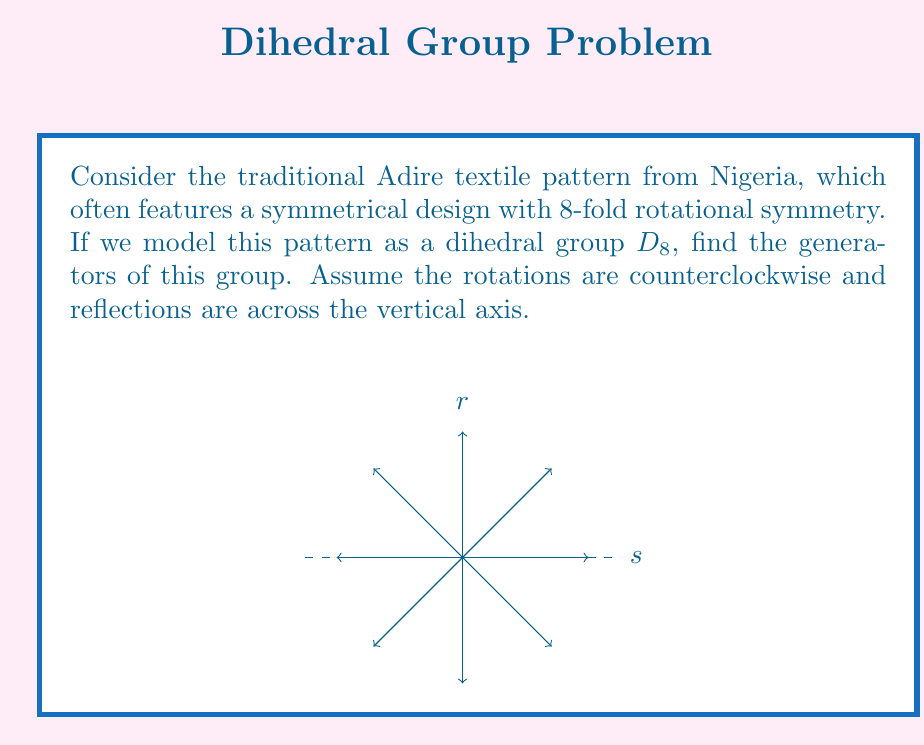Can you answer this question? To find the generators of the dihedral group $D_8$, we need to understand its structure:

1) $D_8$ has 16 elements: 8 rotations (including the identity) and 8 reflections.

2) The standard generators for $D_8$ are:
   - $r$: rotation by $45^\circ$ (counterclockwise)
   - $s$: reflection across the vertical axis

3) Properties of these generators:
   - $r^8 = e$ (identity)
   - $s^2 = e$
   - $srs = r^{-1}$

4) We can generate all elements of $D_8$ using these two generators:
   - Rotations: $e, r, r^2, r^3, r^4, r^5, r^6, r^7$
   - Reflections: $s, sr, sr^2, sr^3, sr^4, sr^5, sr^6, sr^7$

5) In the context of the Adire textile pattern:
   - $r$ represents rotating the pattern by $45^\circ$ counterclockwise
   - $s$ represents flipping the pattern across the vertical axis

6) These two operations ($r$ and $s$) are sufficient to generate all symmetries of the Adire pattern, preserving its 8-fold rotational symmetry and reflection symmetry.

Therefore, the generators of the dihedral group $D_8$ associated with this Adire textile pattern are $r$ and $s$.
Answer: $\{r, s\}$, where $r$ is a $45^\circ$ rotation and $s$ is a reflection. 